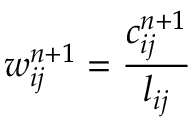Convert formula to latex. <formula><loc_0><loc_0><loc_500><loc_500>w _ { i j } ^ { n + 1 } = \frac { c _ { i j } ^ { n + 1 } } { l _ { i j } }</formula> 